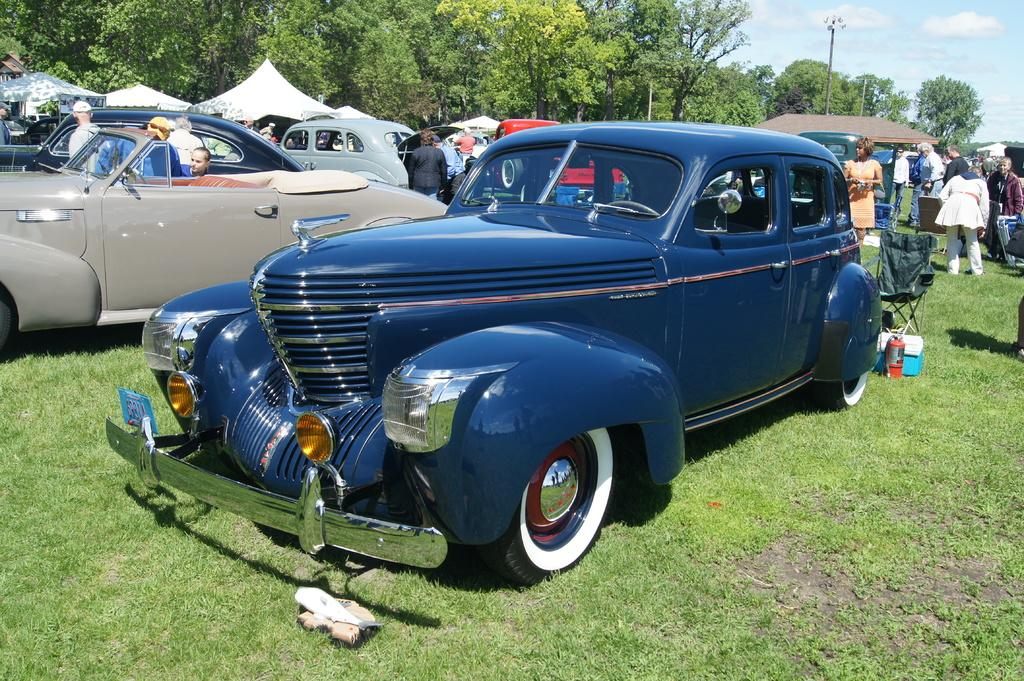What can be seen on the ground in the image? There are vehicles on the ground in the image. What type of vegetation covers the ground? The ground is covered with grass. What type of seating is present in the image? There are chairs in the image. What object can be seen in the image that might be used for storage? There is a box in the image. What type of temporary shelter is present in the image? There are tents in the image. What type of permanent structure is present in the image? There is a house in the image. What type of vertical structures are present in the image? There are poles in the image. Who or what is present in the image? There are people in the image. What type of natural scenery can be seen in the background of the image? There are trees in the background of the image. What can be seen in the sky in the background of the image? The sky is visible in the background of the image, and there are clouds in the sky. What type of cherry is being used to tell a story in the image? There is no cherry present in the image, nor is there any indication of a story being told. How much salt is being used to season the food in the image? There is no food or salt present in the image. 